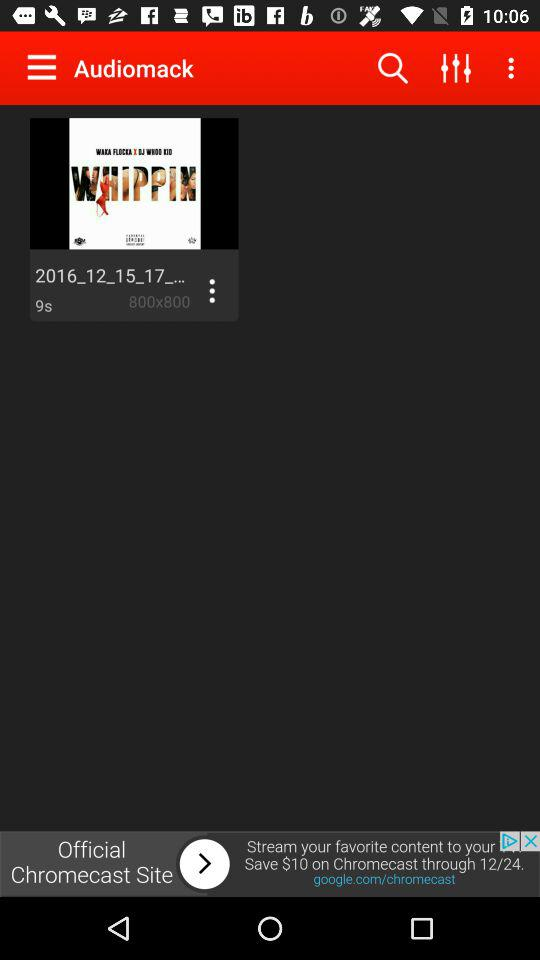What is the duration of the audio? The duration is 9 seconds. 